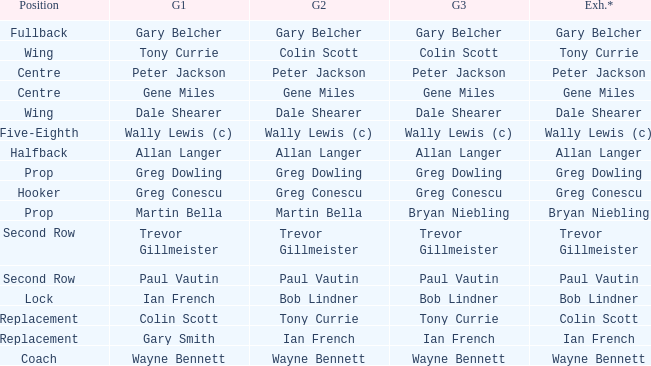What exhibition has greg conescu as game 1? Greg Conescu. 